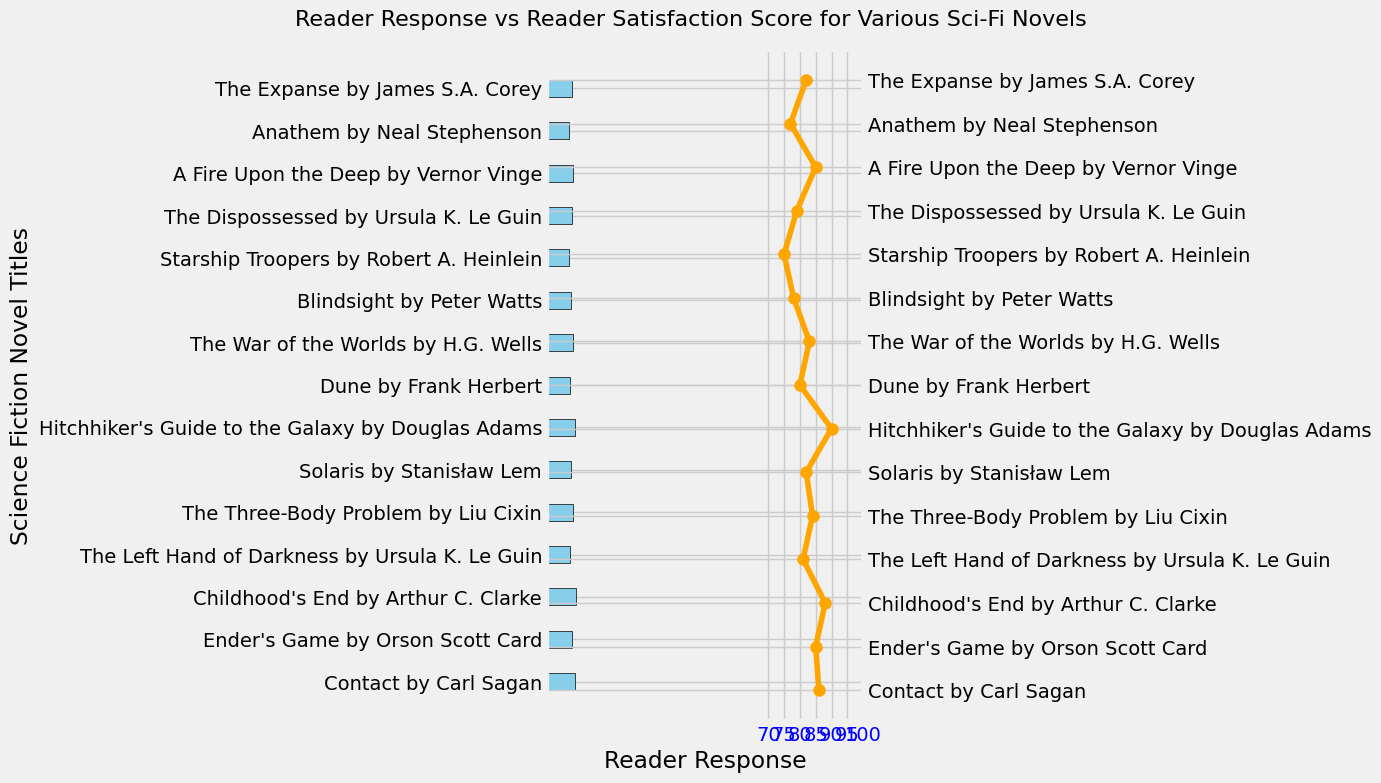Which novel received the highest Reader Response score? The highest point on the axis representing Reader Response indicates the novel. Look for the tallest blue bar in the chart.
Answer: Hitchhiker's Guide to the Galaxy by Douglas Adams What is the difference in Reader Satisfaction Scores between "Contact by Carl Sagan" and "Starship Troopers by Robert A. Heinlein"? Identify the positions of both novels on the orange line, read their respective values, and subtract the smaller value from the larger one. "Contact by Carl Sagan" has a score of 86, and "Starship Troopers by Robert A. Heinlein" has a score of 75. Calculate 86 - 75.
Answer: 11 Which novels have both a Reader Response score of 8 and a Reader Satisfaction Score above 80? Check for bars that reach the value of 8 on the Reader Response axis and then confirm if their corresponding points on the orange line are above 80.
Answer: The Three-Body Problem by Liu Cixin and Ender's Game by Orson Scott Card By how much does "Blindsight by Peter Watts" exceed "Dune by Frank Herbert" in Reader Response score? Find the values of both novels under Reader Response and subtract the value of "Dune by Frank Herbert" from "Blindsight by Peter Watts." The value for "Blindsight" is 10 and for "Dune" is 6. Calculate 10 - 6.
Answer: 4 Which novel has the largest disparity between Reader Response and Reader Satisfaction Score? Find the novel where the difference between the blue bar's height and the corresponding orange point is the largest.
Answer: Hitchhiker's Guide to the Galaxy by Douglas Adams Consider the average Reader Response score of all novels. Is "Solaris by Stanisław Lem" above or below this average? Sum the Reader Response scores of all novels, divide by the number of novels to get the average, then compare "Solaris by Stanisław Lem" to this average. The sum of Reader Response scores is 112, and there are 14 novels, so the average is 112/14 = 8. "Solaris" has a score of 6, which is below the average.
Answer: Below Which novel with a Reader Response score of 9 has the highest Reader Satisfaction Score? Identify all novels with a Reader Response score of 9 and compare their Reader Satisfaction Scores to find the highest. Titles with 9 points are: Childhood's End, The War of the Worlds, The Expanse. Compare their orange points; Childhood's End has 88, The War of the Worlds has 83, and The Expanse has 82.
Answer: Childhood's End by Arthur C. Clarke What is the average Reader Satisfaction Score for the novels with a Reader Satisfaction Score of 9.5? Count the novels for each satisfaction score of 9.5 and sum their Reader Satisfaction Scores. Divide this sum by the number of such novels. "Solaris" and "Blindsight" have scores of 9.5. Their satisfaction scores are 82 and 78 respectively. Calculate (82 + 78)/2.
Answer: 80 Among the novels with a Reader Satisfaction Score above 85, which one has the lowest Reader Response score? Identify novels with a satisfaction score above 85 by looking at the orange points, then find the one with the smallest blue bar. These points are: Contact with 8.8, Hitchhiker's Guide with 8.9, Childhood's End with 9.1. Check their bars: 10, 7, and 9, respectively.
Answer: The Left Hand of Darkness by Ursula K. Le Guin 